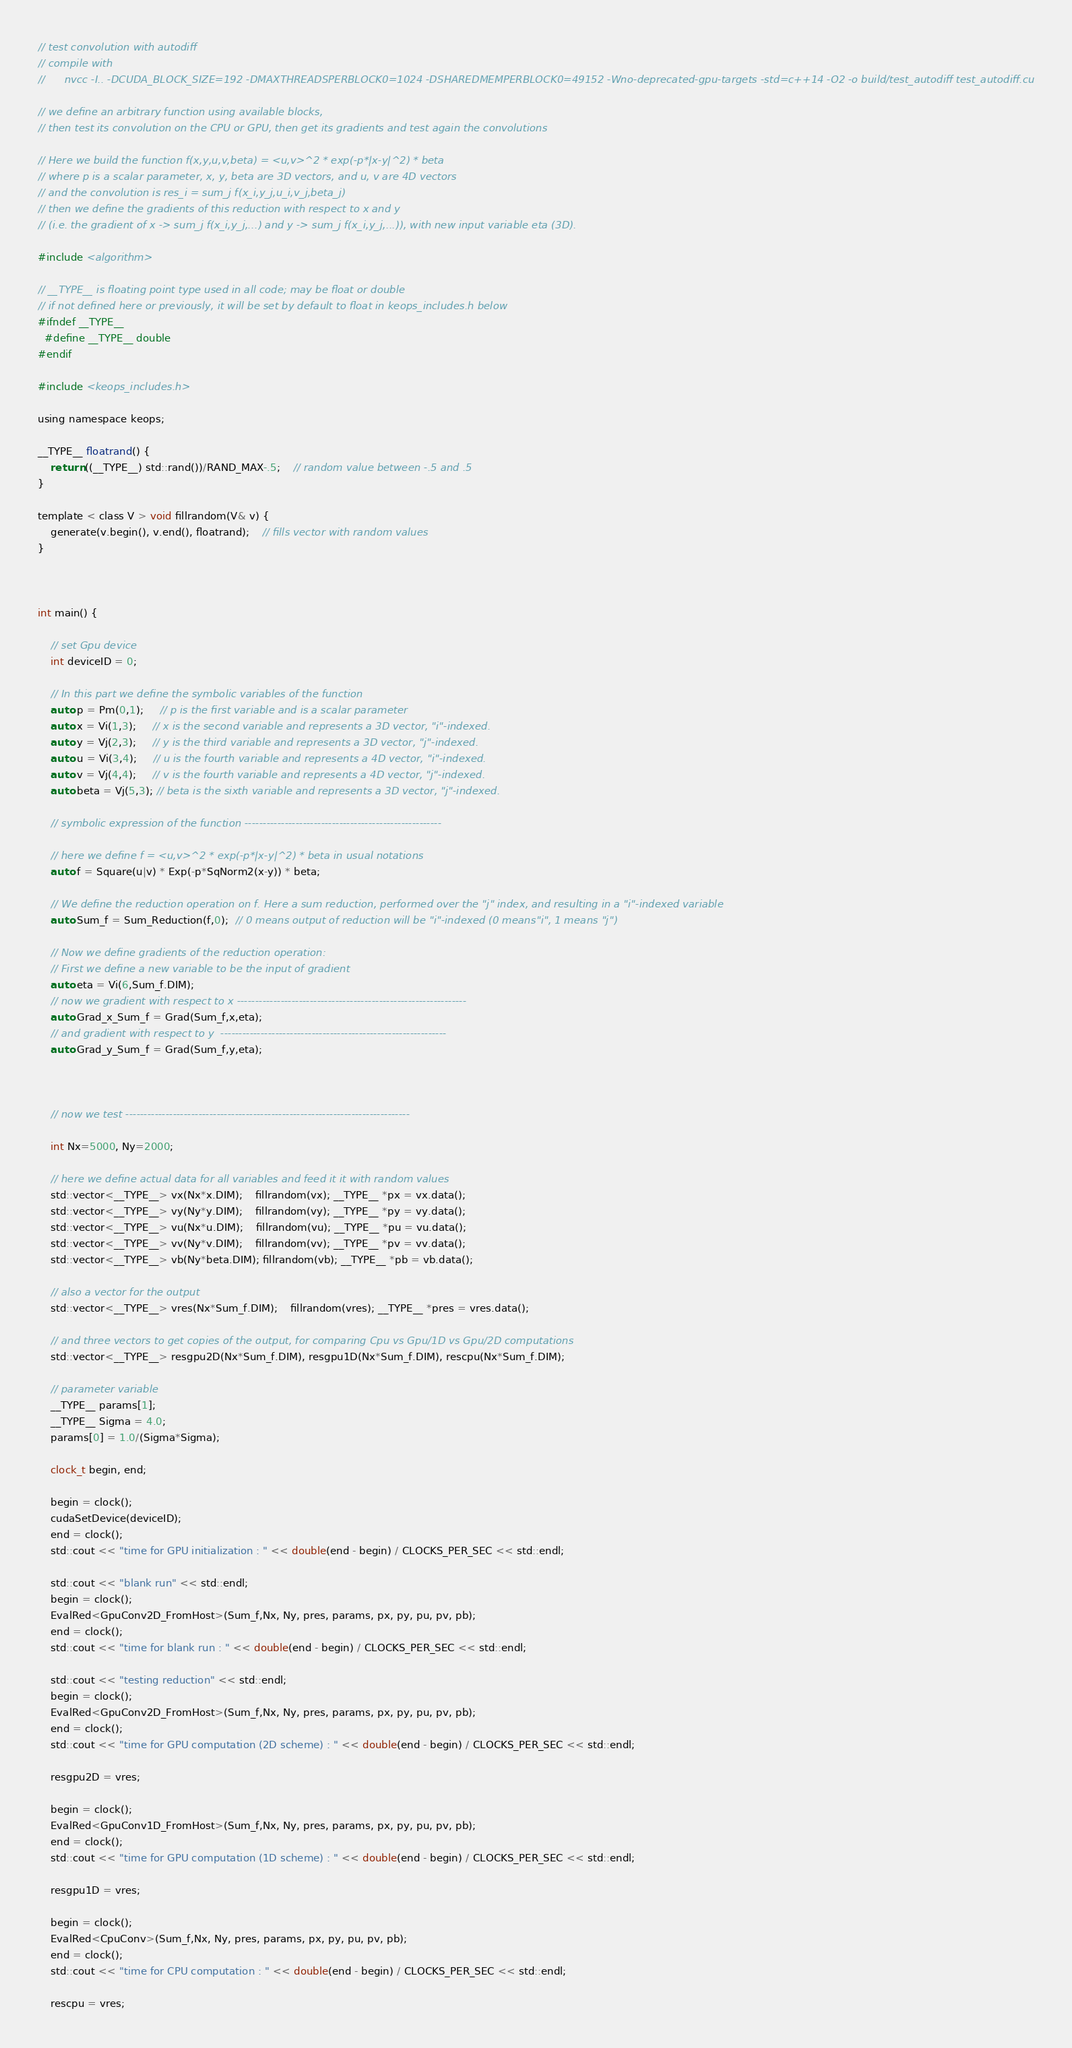Convert code to text. <code><loc_0><loc_0><loc_500><loc_500><_Cuda_>// test convolution with autodiff
// compile with
//		nvcc -I.. -DCUDA_BLOCK_SIZE=192 -DMAXTHREADSPERBLOCK0=1024 -DSHAREDMEMPERBLOCK0=49152 -Wno-deprecated-gpu-targets -std=c++14 -O2 -o build/test_autodiff test_autodiff.cu

// we define an arbitrary function using available blocks,
// then test its convolution on the CPU or GPU, then get its gradients and test again the convolutions

// Here we build the function f(x,y,u,v,beta) = <u,v>^2 * exp(-p*|x-y|^2) * beta
// where p is a scalar parameter, x, y, beta are 3D vectors, and u, v are 4D vectors
// and the convolution is res_i = sum_j f(x_i,y_j,u_i,v_j,beta_j)
// then we define the gradients of this reduction with respect to x and y 
// (i.e. the gradient of x -> sum_j f(x_i,y_j,...) and y -> sum_j f(x_i,y_j,...)), with new input variable eta (3D).

#include <algorithm>

// __TYPE__ is floating point type used in all code; may be float or double
// if not defined here or previously, it will be set by default to float in keops_includes.h below
#ifndef __TYPE__
  #define __TYPE__ double
#endif

#include <keops_includes.h>

using namespace keops;

__TYPE__ floatrand() {
    return ((__TYPE__) std::rand())/RAND_MAX-.5;    // random value between -.5 and .5
}

template < class V > void fillrandom(V& v) {
    generate(v.begin(), v.end(), floatrand);    // fills vector with random values
}



int main() {

    // set Gpu device
    int deviceID = 0;
    
    // In this part we define the symbolic variables of the function
    auto p = Pm(0,1);	 // p is the first variable and is a scalar parameter
    auto x = Vi(1,3); 	 // x is the second variable and represents a 3D vector, "i"-indexed.
    auto y = Vj(2,3); 	 // y is the third variable and represents a 3D vector, "j"-indexed.
    auto u = Vi(3,4); 	 // u is the fourth variable and represents a 4D vector, "i"-indexed.
    auto v = Vj(4,4); 	 // v is the fourth variable and represents a 4D vector, "j"-indexed.
    auto beta = Vj(5,3); // beta is the sixth variable and represents a 3D vector, "j"-indexed.

    // symbolic expression of the function ------------------------------------------------------

    // here we define f = <u,v>^2 * exp(-p*|x-y|^2) * beta in usual notations
    auto f = Square(u|v) * Exp(-p*SqNorm2(x-y)) * beta;
    
    // We define the reduction operation on f. Here a sum reduction, performed over the "j" index, and resulting in a "i"-indexed variable
    auto Sum_f = Sum_Reduction(f,0);  // 0 means output of reduction will be "i"-indexed (0 means"i", 1 means "j")

    // Now we define gradients of the reduction operation:
    // First we define a new variable to be the input of gradient
    auto eta = Vi(6,Sum_f.DIM); 
    // now we gradient with respect to x ---------------------------------------------------------------
    auto Grad_x_Sum_f = Grad(Sum_f,x,eta);
    // and gradient with respect to y  --------------------------------------------------------------
    auto Grad_y_Sum_f = Grad(Sum_f,y,eta);



    // now we test ------------------------------------------------------------------------------

    int Nx=5000, Ny=2000;

    // here we define actual data for all variables and feed it it with random values
    std::vector<__TYPE__> vx(Nx*x.DIM);    fillrandom(vx); __TYPE__ *px = vx.data();
    std::vector<__TYPE__> vy(Ny*y.DIM);    fillrandom(vy); __TYPE__ *py = vy.data();
    std::vector<__TYPE__> vu(Nx*u.DIM);    fillrandom(vu); __TYPE__ *pu = vu.data();
    std::vector<__TYPE__> vv(Ny*v.DIM);    fillrandom(vv); __TYPE__ *pv = vv.data();
    std::vector<__TYPE__> vb(Ny*beta.DIM); fillrandom(vb); __TYPE__ *pb = vb.data();

    // also a vector for the output
    std::vector<__TYPE__> vres(Nx*Sum_f.DIM);    fillrandom(vres); __TYPE__ *pres = vres.data();

    // and three vectors to get copies of the output, for comparing Cpu vs Gpu/1D vs Gpu/2D computations
    std::vector<__TYPE__> resgpu2D(Nx*Sum_f.DIM), resgpu1D(Nx*Sum_f.DIM), rescpu(Nx*Sum_f.DIM);

    // parameter variable
    __TYPE__ params[1];
    __TYPE__ Sigma = 4.0;
    params[0] = 1.0/(Sigma*Sigma);

    clock_t begin, end;

    begin = clock();
    cudaSetDevice(deviceID);        
    end = clock();
    std::cout << "time for GPU initialization : " << double(end - begin) / CLOCKS_PER_SEC << std::endl;

    std::cout << "blank run" << std::endl;
    begin = clock();
    EvalRed<GpuConv2D_FromHost>(Sum_f,Nx, Ny, pres, params, px, py, pu, pv, pb);
    end = clock();
    std::cout << "time for blank run : " << double(end - begin) / CLOCKS_PER_SEC << std::endl;

    std::cout << "testing reduction" << std::endl;
    begin = clock();
    EvalRed<GpuConv2D_FromHost>(Sum_f,Nx, Ny, pres, params, px, py, pu, pv, pb);
    end = clock();
    std::cout << "time for GPU computation (2D scheme) : " << double(end - begin) / CLOCKS_PER_SEC << std::endl;

    resgpu2D = vres;

    begin = clock();
    EvalRed<GpuConv1D_FromHost>(Sum_f,Nx, Ny, pres, params, px, py, pu, pv, pb);
    end = clock();
    std::cout << "time for GPU computation (1D scheme) : " << double(end - begin) / CLOCKS_PER_SEC << std::endl;

    resgpu1D = vres;

    begin = clock();
    EvalRed<CpuConv>(Sum_f,Nx, Ny, pres, params, px, py, pu, pv, pb);
    end = clock();
    std::cout << "time for CPU computation : " << double(end - begin) / CLOCKS_PER_SEC << std::endl;

    rescpu = vres;
</code> 